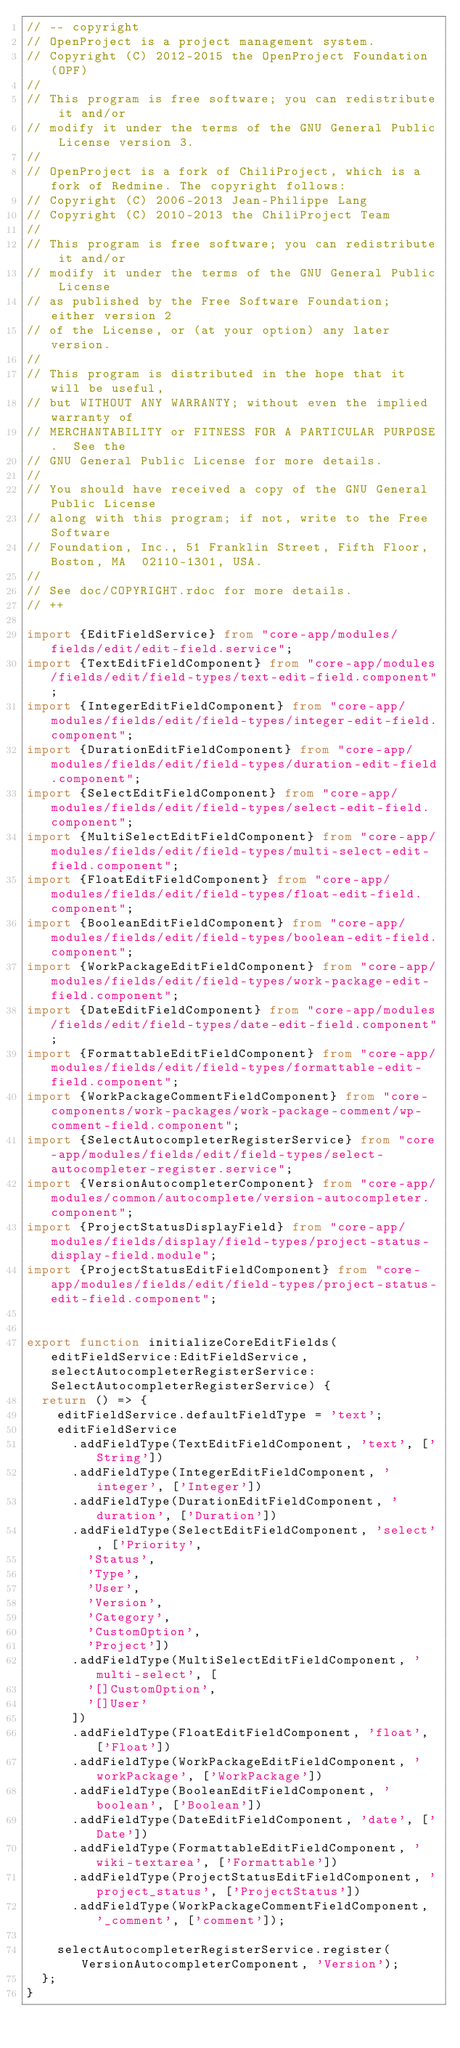Convert code to text. <code><loc_0><loc_0><loc_500><loc_500><_TypeScript_>// -- copyright
// OpenProject is a project management system.
// Copyright (C) 2012-2015 the OpenProject Foundation (OPF)
//
// This program is free software; you can redistribute it and/or
// modify it under the terms of the GNU General Public License version 3.
//
// OpenProject is a fork of ChiliProject, which is a fork of Redmine. The copyright follows:
// Copyright (C) 2006-2013 Jean-Philippe Lang
// Copyright (C) 2010-2013 the ChiliProject Team
//
// This program is free software; you can redistribute it and/or
// modify it under the terms of the GNU General Public License
// as published by the Free Software Foundation; either version 2
// of the License, or (at your option) any later version.
//
// This program is distributed in the hope that it will be useful,
// but WITHOUT ANY WARRANTY; without even the implied warranty of
// MERCHANTABILITY or FITNESS FOR A PARTICULAR PURPOSE.  See the
// GNU General Public License for more details.
//
// You should have received a copy of the GNU General Public License
// along with this program; if not, write to the Free Software
// Foundation, Inc., 51 Franklin Street, Fifth Floor, Boston, MA  02110-1301, USA.
//
// See doc/COPYRIGHT.rdoc for more details.
// ++

import {EditFieldService} from "core-app/modules/fields/edit/edit-field.service";
import {TextEditFieldComponent} from "core-app/modules/fields/edit/field-types/text-edit-field.component";
import {IntegerEditFieldComponent} from "core-app/modules/fields/edit/field-types/integer-edit-field.component";
import {DurationEditFieldComponent} from "core-app/modules/fields/edit/field-types/duration-edit-field.component";
import {SelectEditFieldComponent} from "core-app/modules/fields/edit/field-types/select-edit-field.component";
import {MultiSelectEditFieldComponent} from "core-app/modules/fields/edit/field-types/multi-select-edit-field.component";
import {FloatEditFieldComponent} from "core-app/modules/fields/edit/field-types/float-edit-field.component";
import {BooleanEditFieldComponent} from "core-app/modules/fields/edit/field-types/boolean-edit-field.component";
import {WorkPackageEditFieldComponent} from "core-app/modules/fields/edit/field-types/work-package-edit-field.component";
import {DateEditFieldComponent} from "core-app/modules/fields/edit/field-types/date-edit-field.component";
import {FormattableEditFieldComponent} from "core-app/modules/fields/edit/field-types/formattable-edit-field.component";
import {WorkPackageCommentFieldComponent} from "core-components/work-packages/work-package-comment/wp-comment-field.component";
import {SelectAutocompleterRegisterService} from "core-app/modules/fields/edit/field-types/select-autocompleter-register.service";
import {VersionAutocompleterComponent} from "core-app/modules/common/autocomplete/version-autocompleter.component";
import {ProjectStatusDisplayField} from "core-app/modules/fields/display/field-types/project-status-display-field.module";
import {ProjectStatusEditFieldComponent} from "core-app/modules/fields/edit/field-types/project-status-edit-field.component";


export function initializeCoreEditFields(editFieldService:EditFieldService, selectAutocompleterRegisterService:SelectAutocompleterRegisterService) {
  return () => {
    editFieldService.defaultFieldType = 'text';
    editFieldService
      .addFieldType(TextEditFieldComponent, 'text', ['String'])
      .addFieldType(IntegerEditFieldComponent, 'integer', ['Integer'])
      .addFieldType(DurationEditFieldComponent, 'duration', ['Duration'])
      .addFieldType(SelectEditFieldComponent, 'select', ['Priority',
        'Status',
        'Type',
        'User',
        'Version',
        'Category',
        'CustomOption',
        'Project'])
      .addFieldType(MultiSelectEditFieldComponent, 'multi-select', [
        '[]CustomOption',
        '[]User'
      ])
      .addFieldType(FloatEditFieldComponent, 'float', ['Float'])
      .addFieldType(WorkPackageEditFieldComponent, 'workPackage', ['WorkPackage'])
      .addFieldType(BooleanEditFieldComponent, 'boolean', ['Boolean'])
      .addFieldType(DateEditFieldComponent, 'date', ['Date'])
      .addFieldType(FormattableEditFieldComponent, 'wiki-textarea', ['Formattable'])
      .addFieldType(ProjectStatusEditFieldComponent, 'project_status', ['ProjectStatus'])
      .addFieldType(WorkPackageCommentFieldComponent, '_comment', ['comment']);

    selectAutocompleterRegisterService.register(VersionAutocompleterComponent, 'Version');
  };
}
</code> 